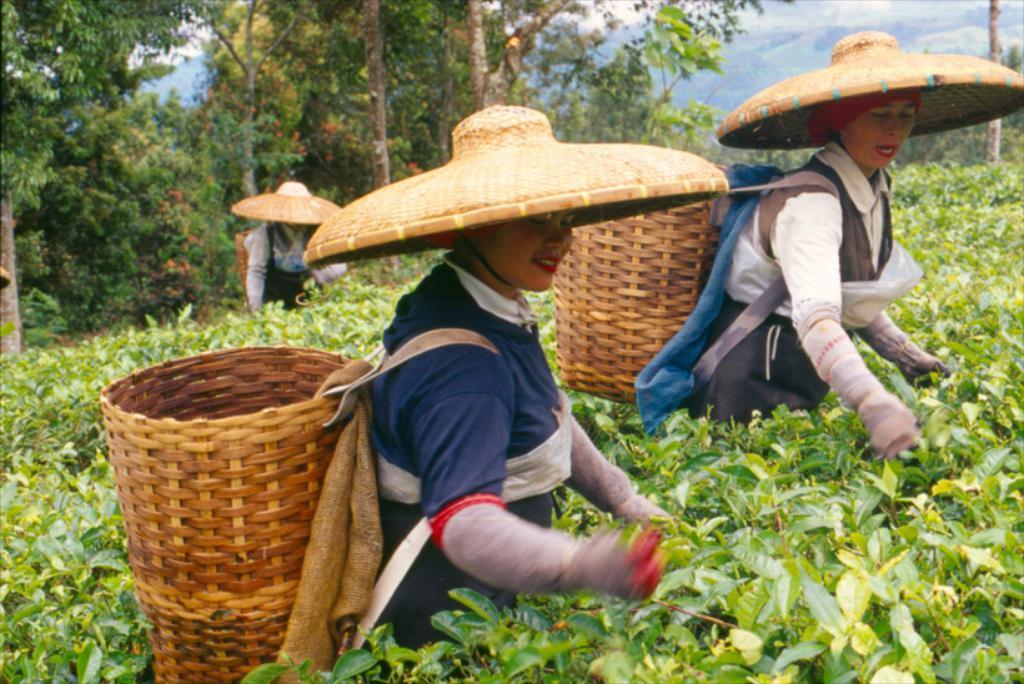Please provide a concise description of this image. In this image, we can see people wearing hats and are carrying baskets and bags. At the bottom, there are plants and in the background, there are trees and we can see a pole. At the top, there are clouds in the sky. 